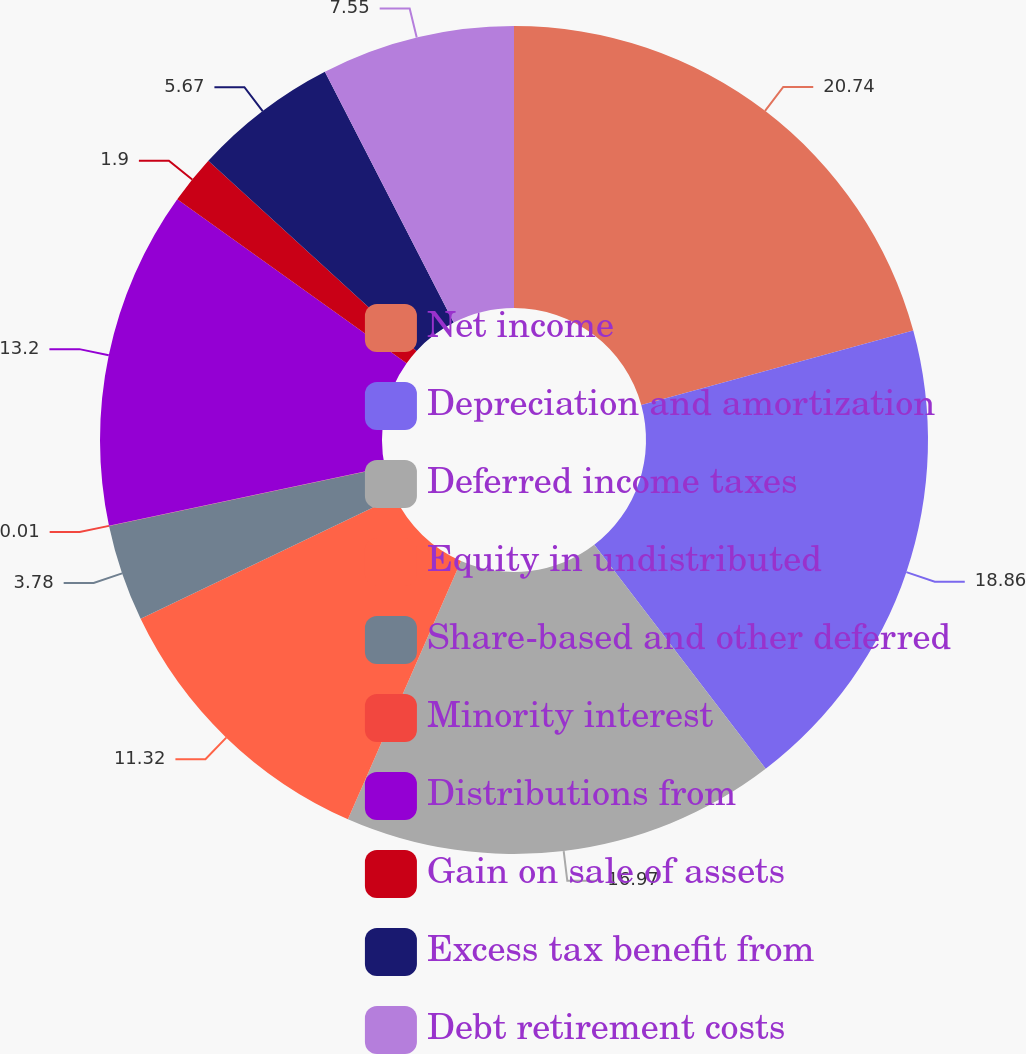<chart> <loc_0><loc_0><loc_500><loc_500><pie_chart><fcel>Net income<fcel>Depreciation and amortization<fcel>Deferred income taxes<fcel>Equity in undistributed<fcel>Share-based and other deferred<fcel>Minority interest<fcel>Distributions from<fcel>Gain on sale of assets<fcel>Excess tax benefit from<fcel>Debt retirement costs<nl><fcel>20.74%<fcel>18.86%<fcel>16.97%<fcel>11.32%<fcel>3.78%<fcel>0.01%<fcel>13.2%<fcel>1.9%<fcel>5.67%<fcel>7.55%<nl></chart> 